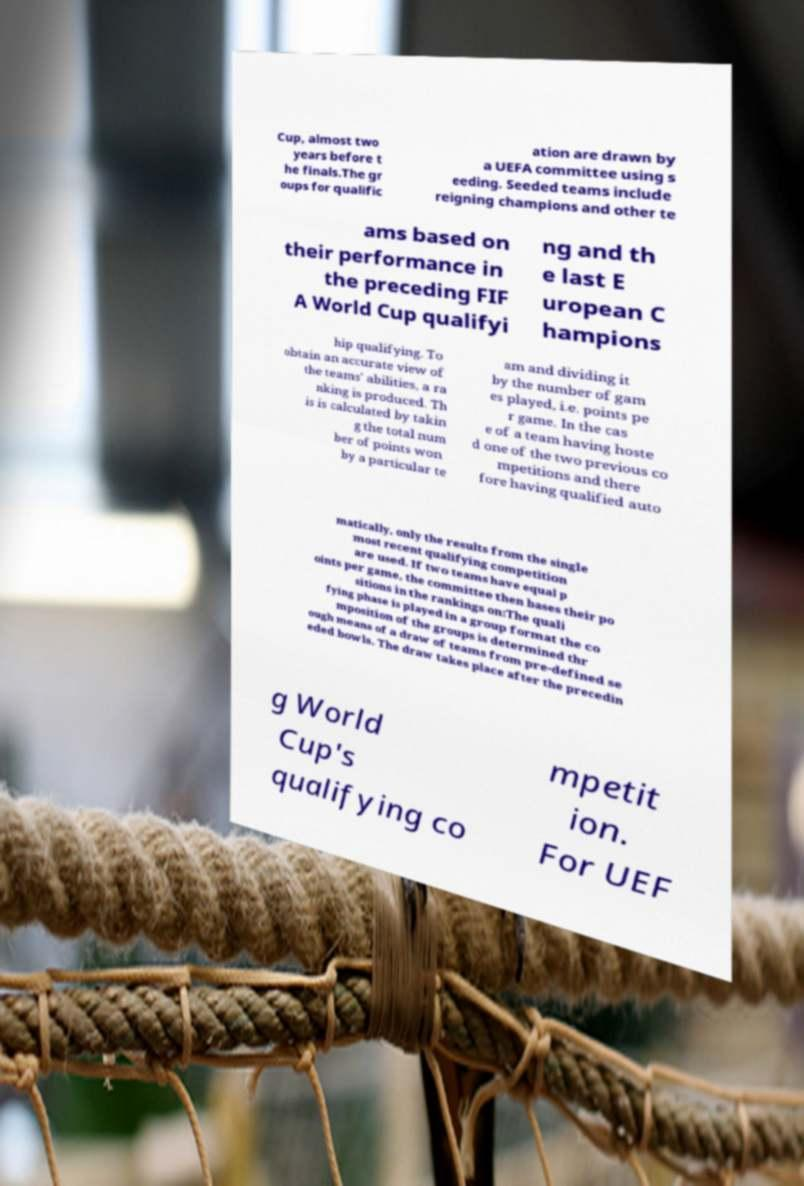For documentation purposes, I need the text within this image transcribed. Could you provide that? Cup, almost two years before t he finals.The gr oups for qualific ation are drawn by a UEFA committee using s eeding. Seeded teams include reigning champions and other te ams based on their performance in the preceding FIF A World Cup qualifyi ng and th e last E uropean C hampions hip qualifying. To obtain an accurate view of the teams' abilities, a ra nking is produced. Th is is calculated by takin g the total num ber of points won by a particular te am and dividing it by the number of gam es played, i.e. points pe r game. In the cas e of a team having hoste d one of the two previous co mpetitions and there fore having qualified auto matically, only the results from the single most recent qualifying competition are used. If two teams have equal p oints per game, the committee then bases their po sitions in the rankings on:The quali fying phase is played in a group format the co mposition of the groups is determined thr ough means of a draw of teams from pre-defined se eded bowls. The draw takes place after the precedin g World Cup's qualifying co mpetit ion. For UEF 